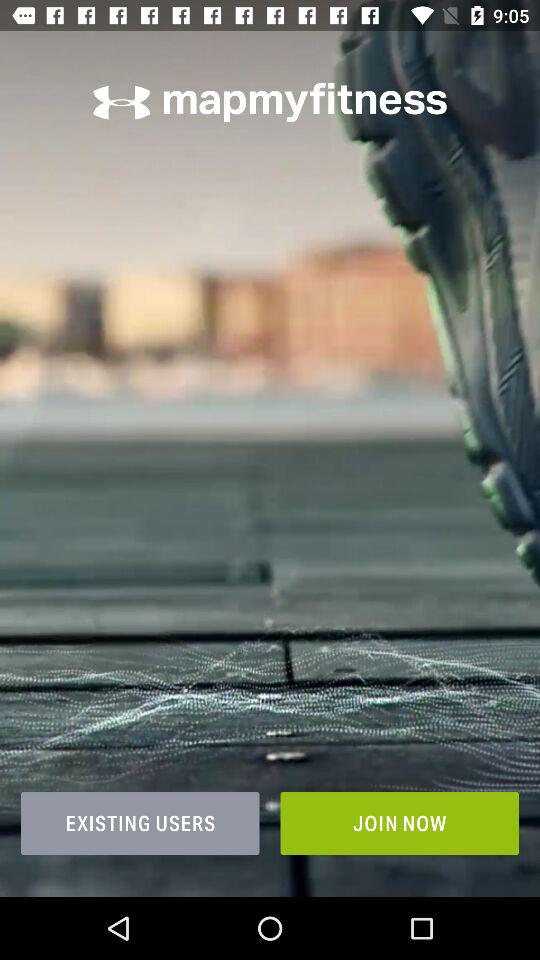What is the application name? The application name is "mapmyfitness". 